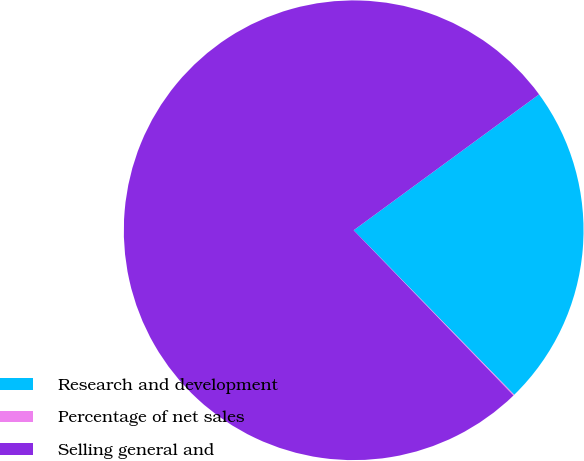Convert chart to OTSL. <chart><loc_0><loc_0><loc_500><loc_500><pie_chart><fcel>Research and development<fcel>Percentage of net sales<fcel>Selling general and<nl><fcel>22.76%<fcel>0.07%<fcel>77.17%<nl></chart> 